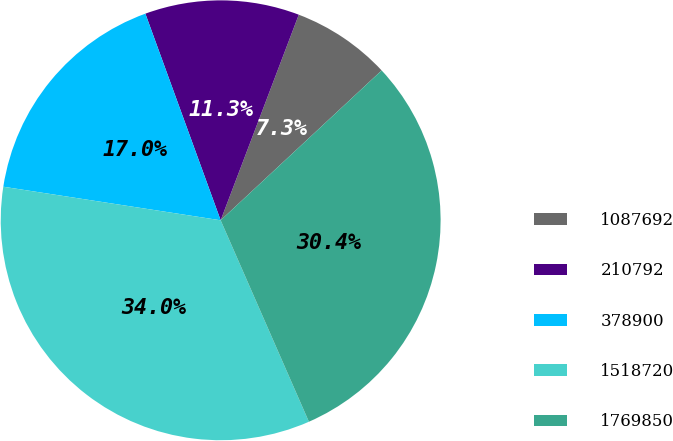Convert chart. <chart><loc_0><loc_0><loc_500><loc_500><pie_chart><fcel>1087692<fcel>210792<fcel>378900<fcel>1518720<fcel>1769850<nl><fcel>7.29%<fcel>11.34%<fcel>17.0%<fcel>34.01%<fcel>30.36%<nl></chart> 